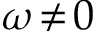<formula> <loc_0><loc_0><loc_500><loc_500>\omega \, \neq \, 0</formula> 